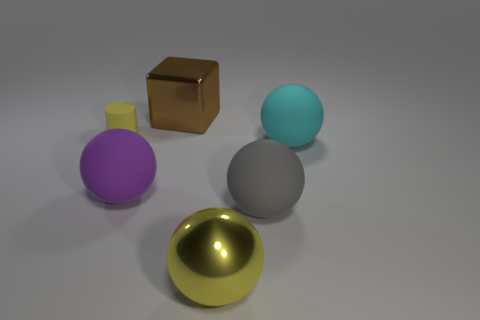Is there any other thing that has the same size as the yellow cylinder?
Offer a terse response. No. There is a cyan rubber ball; how many matte cylinders are right of it?
Your response must be concise. 0. Are there any purple rubber balls that are in front of the big matte thing that is on the left side of the large thing behind the large cyan rubber object?
Provide a short and direct response. No. What number of yellow things are the same size as the cyan rubber sphere?
Your answer should be compact. 1. What material is the big sphere on the left side of the yellow object that is in front of the large purple rubber ball made of?
Your answer should be very brief. Rubber. There is a big metal object behind the big rubber ball that is behind the large matte ball that is on the left side of the big brown metallic block; what shape is it?
Ensure brevity in your answer.  Cube. Does the yellow thing right of the small yellow object have the same shape as the large rubber thing on the left side of the metallic cube?
Provide a short and direct response. Yes. How many other objects are the same material as the gray ball?
Offer a terse response. 3. There is a purple thing that is made of the same material as the small yellow cylinder; what shape is it?
Ensure brevity in your answer.  Sphere. Do the gray matte sphere and the brown shiny cube have the same size?
Ensure brevity in your answer.  Yes. 